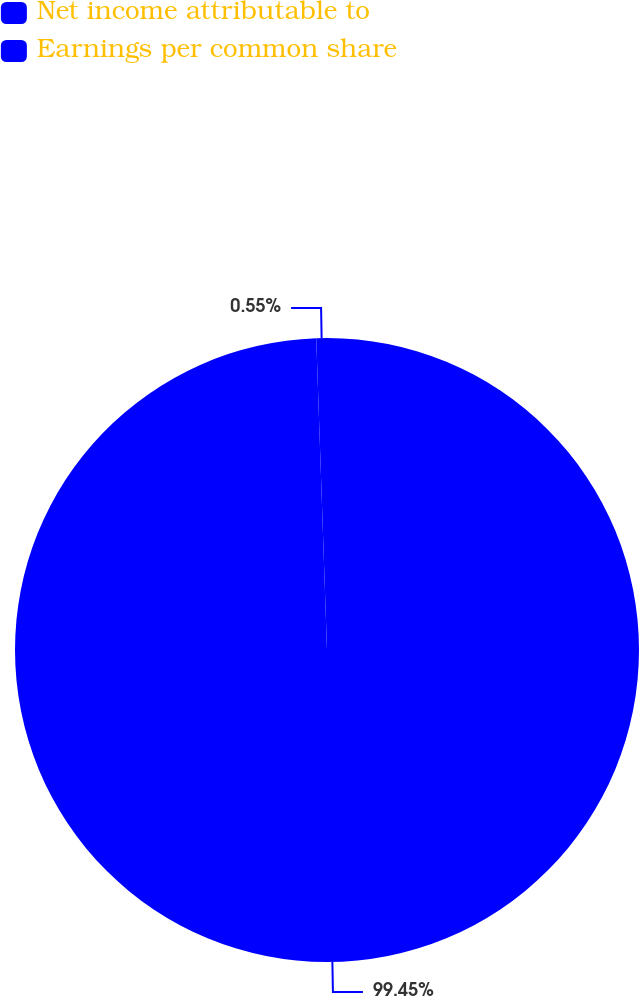Convert chart to OTSL. <chart><loc_0><loc_0><loc_500><loc_500><pie_chart><fcel>Net income attributable to<fcel>Earnings per common share<nl><fcel>99.45%<fcel>0.55%<nl></chart> 